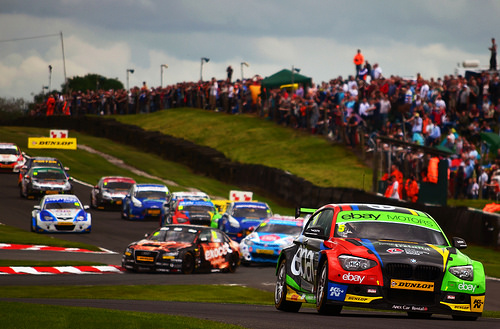<image>
Is the sticker on the car? Yes. Looking at the image, I can see the sticker is positioned on top of the car, with the car providing support. Is there a pole behind the car? Yes. From this viewpoint, the pole is positioned behind the car, with the car partially or fully occluding the pole. Where is the crowd in relation to the track? Is it next to the track? Yes. The crowd is positioned adjacent to the track, located nearby in the same general area. 